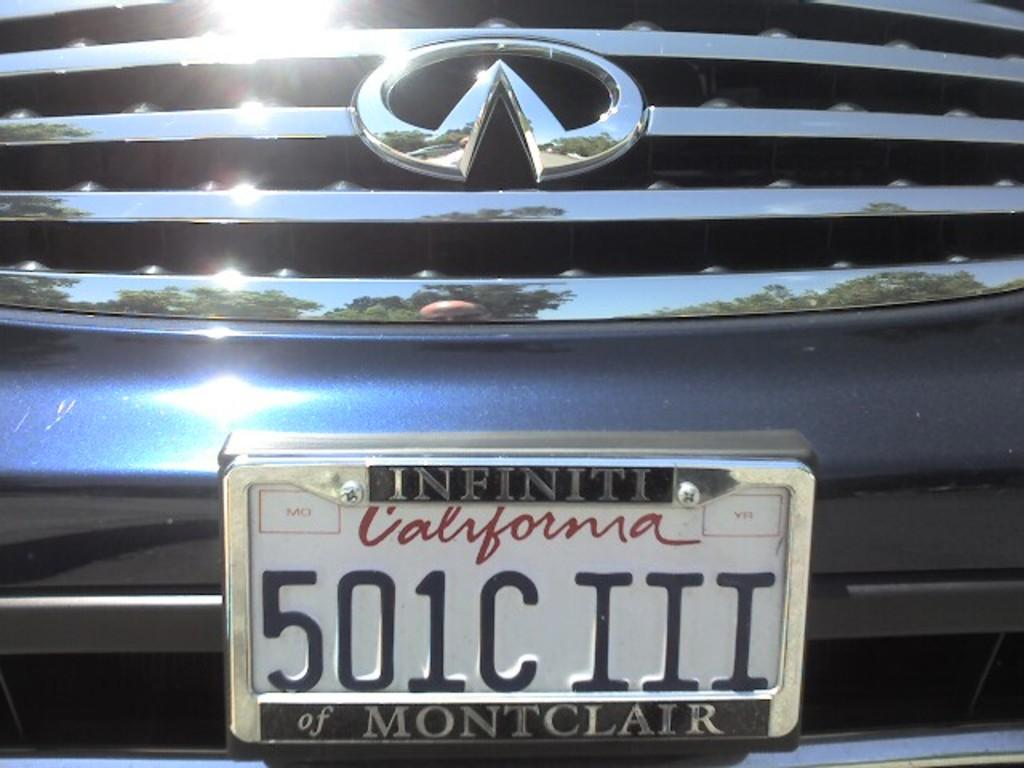<image>
Describe the image concisely. An Infinity with a California tag that reads 501C III. 